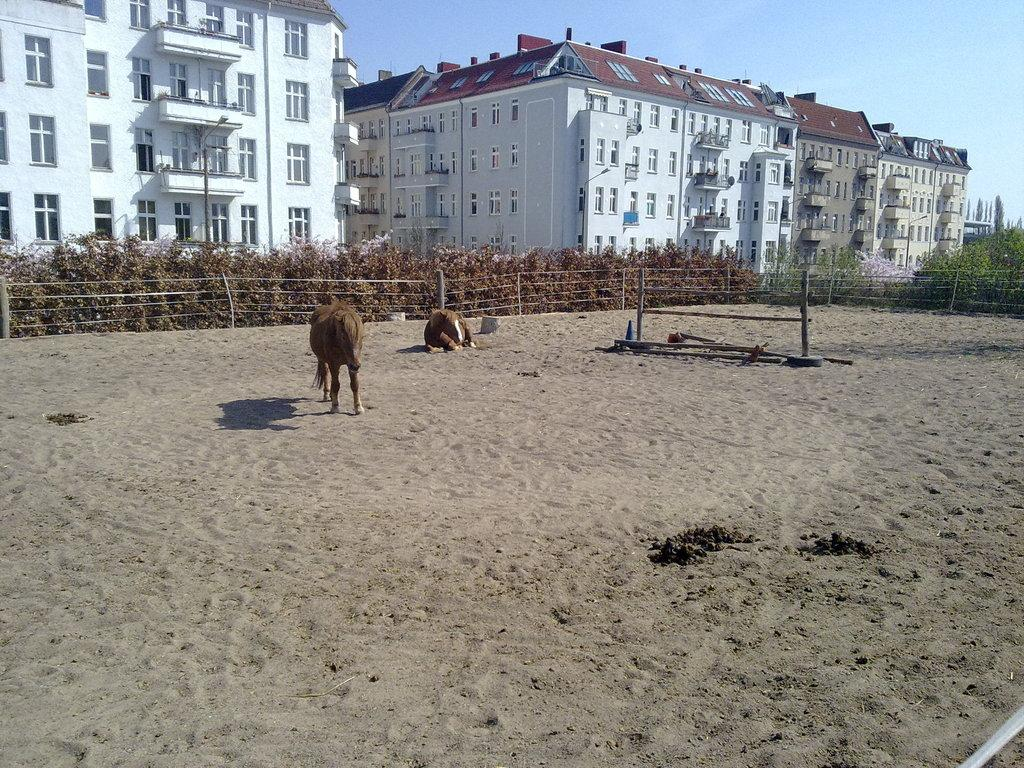What type of terrain is visible in the front of the image? There is sand on the ground in the front of the image. What is located in the center of the image? There are animals in the center of the image. What can be seen in the background of the image? There are plants and buildings in the background of the image. What type of vegetation is on the right side of the image? There are trees on the right side of the image. What type of wax can be seen melting on the animals in the image? There is no wax present in the image; the animals are not melting wax. What things are the animals doing in the image? The provided facts do not mention any specific actions or activities of the animals, so we cannot determine what they are doing. 